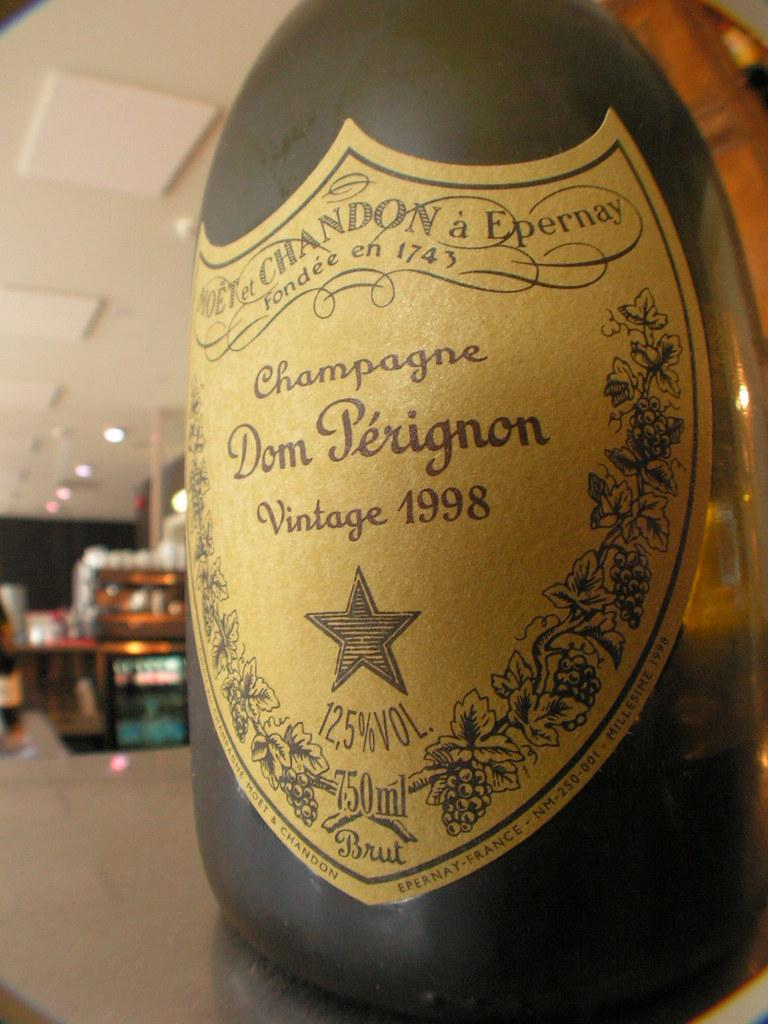<image>
Write a terse but informative summary of the picture. The logo for Don Perignon branded champagne with a gold background. 